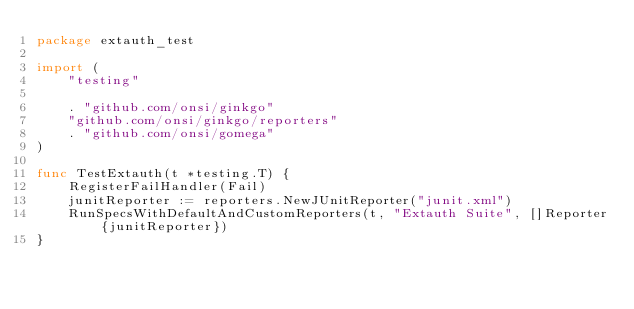<code> <loc_0><loc_0><loc_500><loc_500><_Go_>package extauth_test

import (
	"testing"

	. "github.com/onsi/ginkgo"
	"github.com/onsi/ginkgo/reporters"
	. "github.com/onsi/gomega"
)

func TestExtauth(t *testing.T) {
	RegisterFailHandler(Fail)
	junitReporter := reporters.NewJUnitReporter("junit.xml")
	RunSpecsWithDefaultAndCustomReporters(t, "Extauth Suite", []Reporter{junitReporter})
}
</code> 